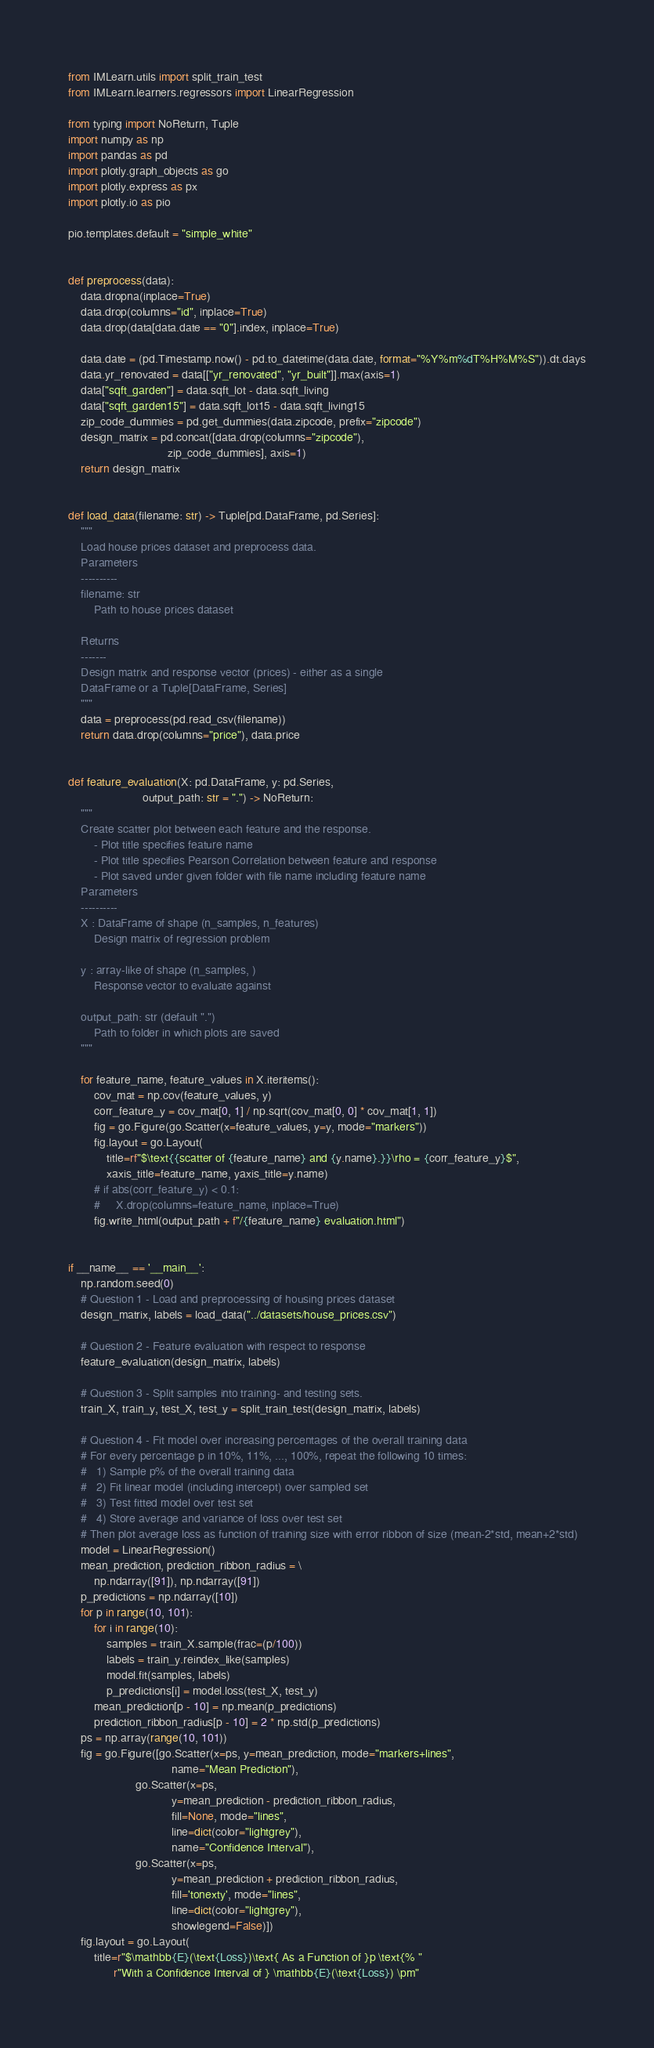Convert code to text. <code><loc_0><loc_0><loc_500><loc_500><_Python_>from IMLearn.utils import split_train_test
from IMLearn.learners.regressors import LinearRegression

from typing import NoReturn, Tuple
import numpy as np
import pandas as pd
import plotly.graph_objects as go
import plotly.express as px
import plotly.io as pio

pio.templates.default = "simple_white"


def preprocess(data):
    data.dropna(inplace=True)
    data.drop(columns="id", inplace=True)
    data.drop(data[data.date == "0"].index, inplace=True)

    data.date = (pd.Timestamp.now() - pd.to_datetime(data.date, format="%Y%m%dT%H%M%S")).dt.days
    data.yr_renovated = data[["yr_renovated", "yr_built"]].max(axis=1)
    data["sqft_garden"] = data.sqft_lot - data.sqft_living
    data["sqft_garden15"] = data.sqft_lot15 - data.sqft_living15
    zip_code_dummies = pd.get_dummies(data.zipcode, prefix="zipcode")
    design_matrix = pd.concat([data.drop(columns="zipcode"),
                               zip_code_dummies], axis=1)
    return design_matrix


def load_data(filename: str) -> Tuple[pd.DataFrame, pd.Series]:
    """
    Load house prices dataset and preprocess data.
    Parameters
    ----------
    filename: str
        Path to house prices dataset

    Returns
    -------
    Design matrix and response vector (prices) - either as a single
    DataFrame or a Tuple[DataFrame, Series]
    """
    data = preprocess(pd.read_csv(filename))
    return data.drop(columns="price"), data.price


def feature_evaluation(X: pd.DataFrame, y: pd.Series,
                       output_path: str = ".") -> NoReturn:
    """
    Create scatter plot between each feature and the response.
        - Plot title specifies feature name
        - Plot title specifies Pearson Correlation between feature and response
        - Plot saved under given folder with file name including feature name
    Parameters
    ----------
    X : DataFrame of shape (n_samples, n_features)
        Design matrix of regression problem

    y : array-like of shape (n_samples, )
        Response vector to evaluate against

    output_path: str (default ".")
        Path to folder in which plots are saved
    """

    for feature_name, feature_values in X.iteritems():
        cov_mat = np.cov(feature_values, y)
        corr_feature_y = cov_mat[0, 1] / np.sqrt(cov_mat[0, 0] * cov_mat[1, 1])
        fig = go.Figure(go.Scatter(x=feature_values, y=y, mode="markers"))
        fig.layout = go.Layout(
            title=rf"$\text{{scatter of {feature_name} and {y.name}.}}\rho = {corr_feature_y}$",
            xaxis_title=feature_name, yaxis_title=y.name)
        # if abs(corr_feature_y) < 0.1:
        #     X.drop(columns=feature_name, inplace=True)
        fig.write_html(output_path + f"/{feature_name} evaluation.html")


if __name__ == '__main__':
    np.random.seed(0)
    # Question 1 - Load and preprocessing of housing prices dataset
    design_matrix, labels = load_data("../datasets/house_prices.csv")

    # Question 2 - Feature evaluation with respect to response
    feature_evaluation(design_matrix, labels)

    # Question 3 - Split samples into training- and testing sets.
    train_X, train_y, test_X, test_y = split_train_test(design_matrix, labels)

    # Question 4 - Fit model over increasing percentages of the overall training data
    # For every percentage p in 10%, 11%, ..., 100%, repeat the following 10 times:
    #   1) Sample p% of the overall training data
    #   2) Fit linear model (including intercept) over sampled set
    #   3) Test fitted model over test set
    #   4) Store average and variance of loss over test set
    # Then plot average loss as function of training size with error ribbon of size (mean-2*std, mean+2*std)
    model = LinearRegression()
    mean_prediction, prediction_ribbon_radius = \
        np.ndarray([91]), np.ndarray([91])
    p_predictions = np.ndarray([10])
    for p in range(10, 101):
        for i in range(10):
            samples = train_X.sample(frac=(p/100))
            labels = train_y.reindex_like(samples)
            model.fit(samples, labels)
            p_predictions[i] = model.loss(test_X, test_y)
        mean_prediction[p - 10] = np.mean(p_predictions)
        prediction_ribbon_radius[p - 10] = 2 * np.std(p_predictions)
    ps = np.array(range(10, 101))
    fig = go.Figure([go.Scatter(x=ps, y=mean_prediction, mode="markers+lines",
                                name="Mean Prediction"),
                     go.Scatter(x=ps,
                                y=mean_prediction - prediction_ribbon_radius,
                                fill=None, mode="lines",
                                line=dict(color="lightgrey"),
                                name="Confidence Interval"),
                     go.Scatter(x=ps,
                                y=mean_prediction + prediction_ribbon_radius,
                                fill='tonexty', mode="lines",
                                line=dict(color="lightgrey"),
                                showlegend=False)])
    fig.layout = go.Layout(
        title=r"$\mathbb{E}(\text{Loss})\text{ As a Function of }p \text{% "
              r"With a Confidence Interval of } \mathbb{E}(\text{Loss}) \pm"</code> 